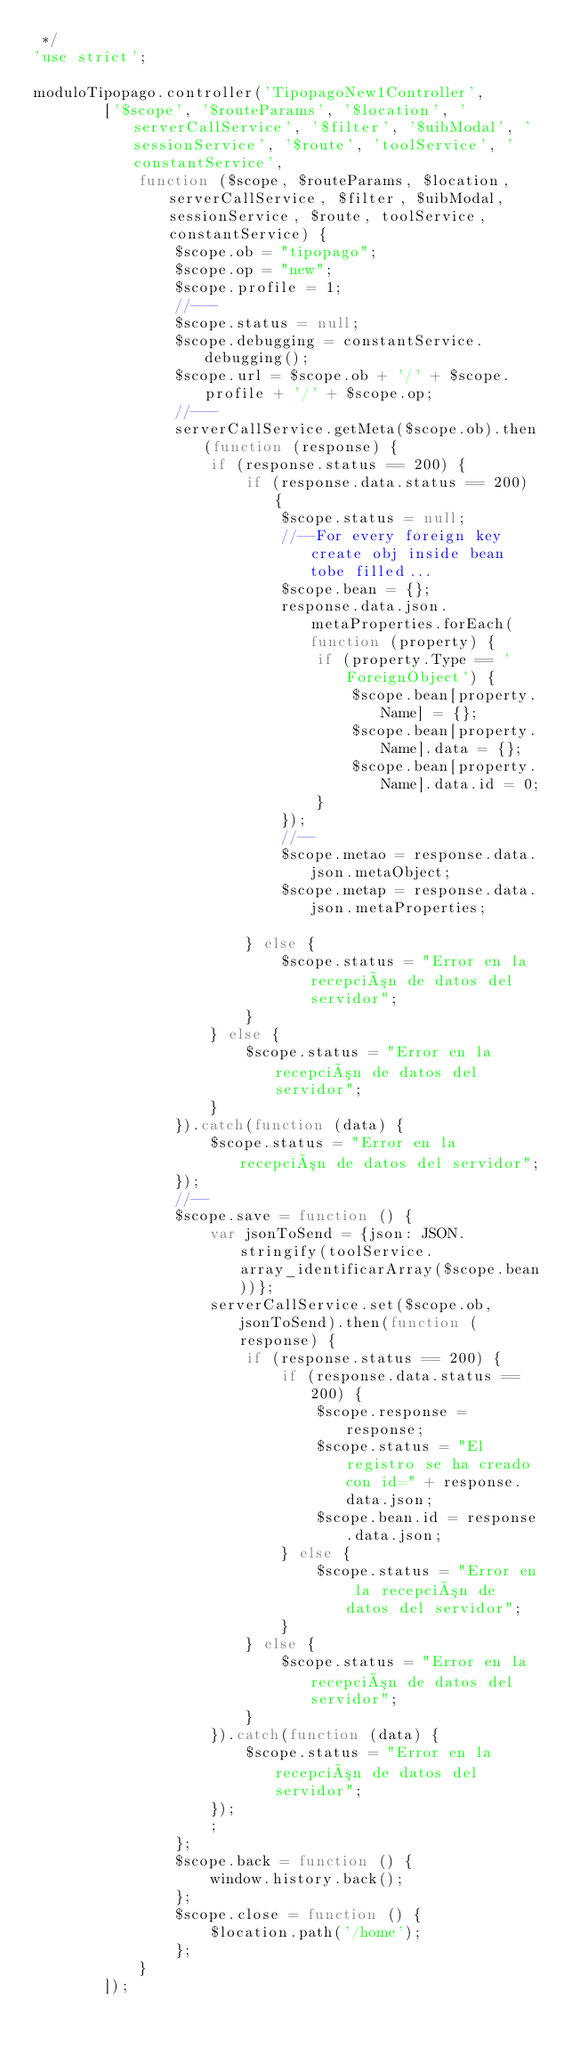<code> <loc_0><loc_0><loc_500><loc_500><_JavaScript_> */
'use strict';

moduloTipopago.controller('TipopagoNew1Controller',
        ['$scope', '$routeParams', '$location', 'serverCallService', '$filter', '$uibModal', 'sessionService', '$route', 'toolService', 'constantService',
            function ($scope, $routeParams, $location, serverCallService, $filter, $uibModal, sessionService, $route, toolService, constantService) {
                $scope.ob = "tipopago";
                $scope.op = "new";
                $scope.profile = 1;
                //---
                $scope.status = null;
                $scope.debugging = constantService.debugging();
                $scope.url = $scope.ob + '/' + $scope.profile + '/' + $scope.op;
                //---
                serverCallService.getMeta($scope.ob).then(function (response) {
                    if (response.status == 200) {
                        if (response.data.status == 200) {
                            $scope.status = null;
                            //--For every foreign key create obj inside bean tobe filled...
                            $scope.bean = {};
                            response.data.json.metaProperties.forEach(function (property) {
                                if (property.Type == 'ForeignObject') {
                                    $scope.bean[property.Name] = {};
                                    $scope.bean[property.Name].data = {};
                                    $scope.bean[property.Name].data.id = 0;
                                }
                            });
                            //--
                            $scope.metao = response.data.json.metaObject;
                            $scope.metap = response.data.json.metaProperties;

                        } else {
                            $scope.status = "Error en la recepción de datos del servidor";
                        }
                    } else {
                        $scope.status = "Error en la recepción de datos del servidor";
                    }
                }).catch(function (data) {
                    $scope.status = "Error en la recepción de datos del servidor";
                });
                //--
                $scope.save = function () {
                    var jsonToSend = {json: JSON.stringify(toolService.array_identificarArray($scope.bean))};
                    serverCallService.set($scope.ob, jsonToSend).then(function (response) {
                        if (response.status == 200) {
                            if (response.data.status == 200) {
                                $scope.response = response;
                                $scope.status = "El registro se ha creado con id=" + response.data.json;
                                $scope.bean.id = response.data.json;
                            } else {
                                $scope.status = "Error en la recepción de datos del servidor";
                            }
                        } else {
                            $scope.status = "Error en la recepción de datos del servidor";
                        }
                    }).catch(function (data) {
                        $scope.status = "Error en la recepción de datos del servidor";
                    });
                    ;
                };
                $scope.back = function () {
                    window.history.back();
                };
                $scope.close = function () {
                    $location.path('/home');
                };
            }
        ]);

</code> 